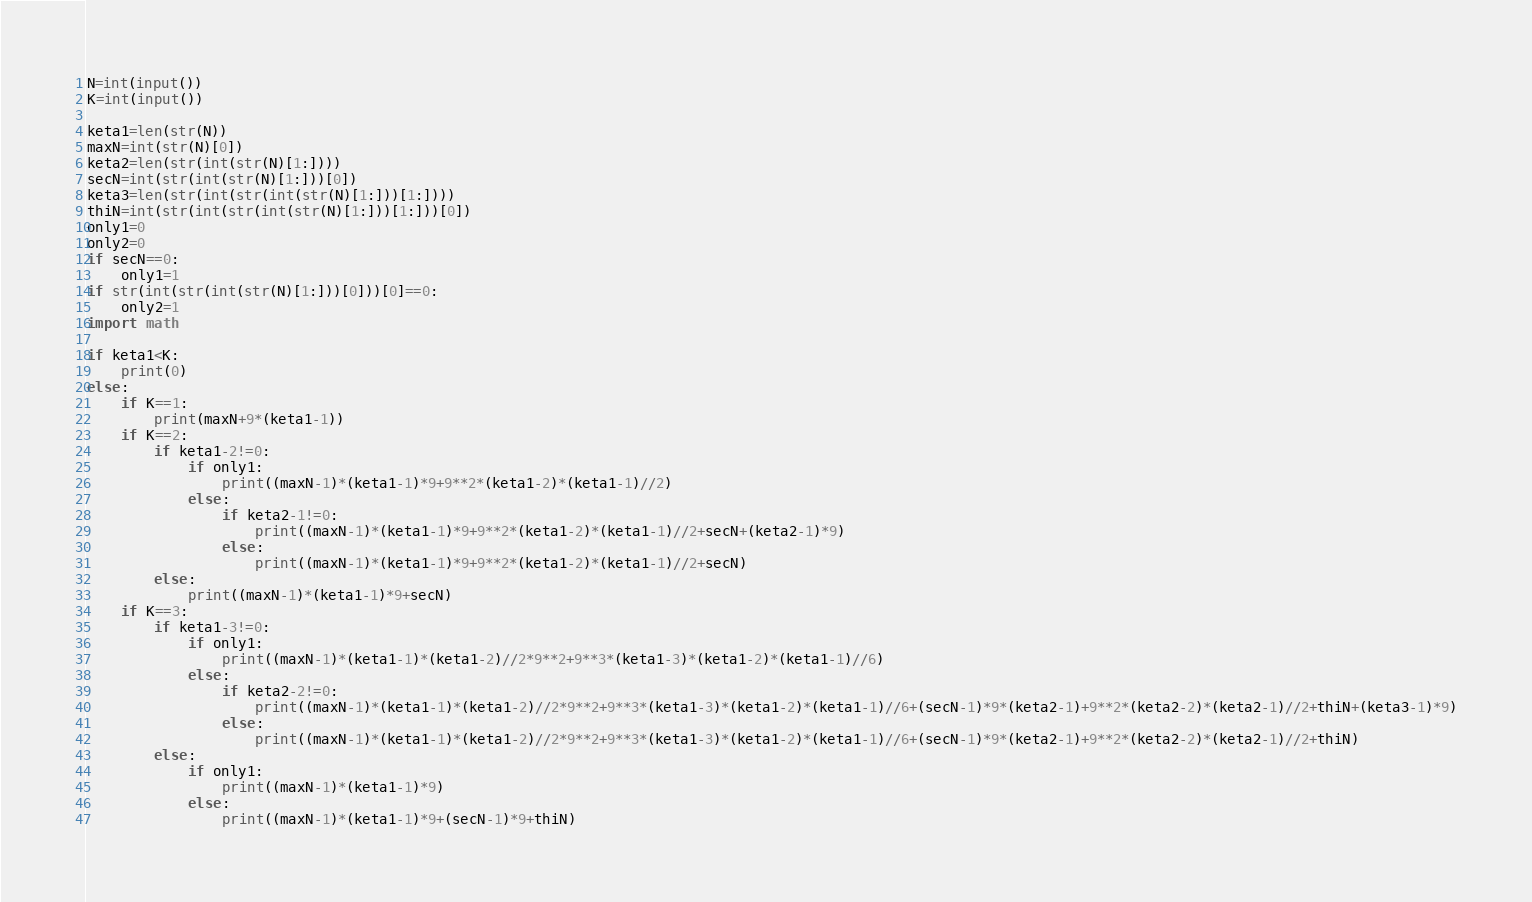<code> <loc_0><loc_0><loc_500><loc_500><_Python_>
N=int(input())
K=int(input())

keta1=len(str(N))
maxN=int(str(N)[0])
keta2=len(str(int(str(N)[1:])))
secN=int(str(int(str(N)[1:]))[0])
keta3=len(str(int(str(int(str(N)[1:]))[1:])))
thiN=int(str(int(str(int(str(N)[1:]))[1:]))[0])
only1=0
only2=0
if secN==0:
    only1=1
if str(int(str(int(str(N)[1:]))[0]))[0]==0:
    only2=1
import math

if keta1<K:
    print(0)
else:
    if K==1:
        print(maxN+9*(keta1-1))
    if K==2:
        if keta1-2!=0:
            if only1:
                print((maxN-1)*(keta1-1)*9+9**2*(keta1-2)*(keta1-1)//2)
            else:
                if keta2-1!=0:
                    print((maxN-1)*(keta1-1)*9+9**2*(keta1-2)*(keta1-1)//2+secN+(keta2-1)*9)
                else:
                    print((maxN-1)*(keta1-1)*9+9**2*(keta1-2)*(keta1-1)//2+secN)
        else:
            print((maxN-1)*(keta1-1)*9+secN)
    if K==3:
        if keta1-3!=0:
            if only1:
                print((maxN-1)*(keta1-1)*(keta1-2)//2*9**2+9**3*(keta1-3)*(keta1-2)*(keta1-1)//6)
            else:
                if keta2-2!=0:
                    print((maxN-1)*(keta1-1)*(keta1-2)//2*9**2+9**3*(keta1-3)*(keta1-2)*(keta1-1)//6+(secN-1)*9*(keta2-1)+9**2*(keta2-2)*(keta2-1)//2+thiN+(keta3-1)*9)
                else:
                    print((maxN-1)*(keta1-1)*(keta1-2)//2*9**2+9**3*(keta1-3)*(keta1-2)*(keta1-1)//6+(secN-1)*9*(keta2-1)+9**2*(keta2-2)*(keta2-1)//2+thiN)
        else:
            if only1:
                print((maxN-1)*(keta1-1)*9)
            else:
                print((maxN-1)*(keta1-1)*9+(secN-1)*9+thiN)

</code> 